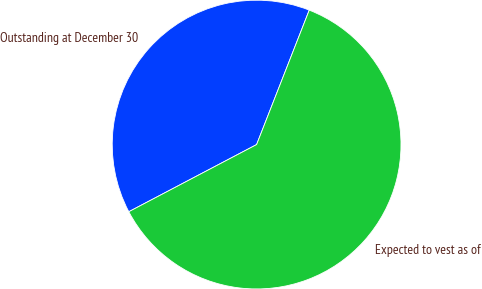Convert chart to OTSL. <chart><loc_0><loc_0><loc_500><loc_500><pie_chart><fcel>Outstanding at December 30<fcel>Expected to vest as of<nl><fcel>38.64%<fcel>61.36%<nl></chart> 